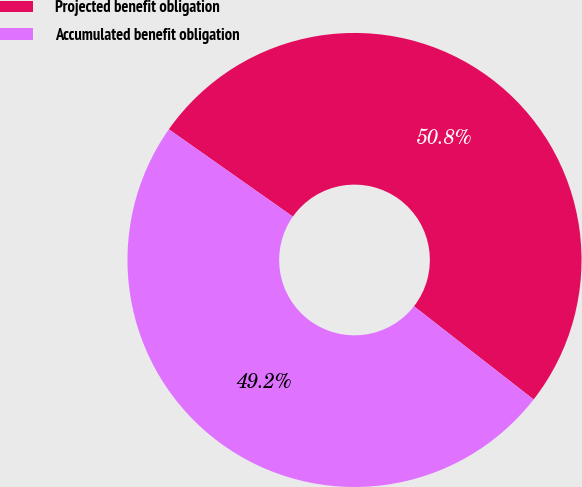Convert chart. <chart><loc_0><loc_0><loc_500><loc_500><pie_chart><fcel>Projected benefit obligation<fcel>Accumulated benefit obligation<nl><fcel>50.77%<fcel>49.23%<nl></chart> 